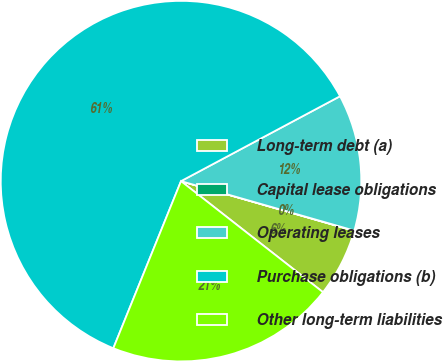Convert chart. <chart><loc_0><loc_0><loc_500><loc_500><pie_chart><fcel>Long-term debt (a)<fcel>Capital lease obligations<fcel>Operating leases<fcel>Purchase obligations (b)<fcel>Other long-term liabilities<nl><fcel>6.12%<fcel>0.02%<fcel>12.23%<fcel>61.07%<fcel>20.56%<nl></chart> 